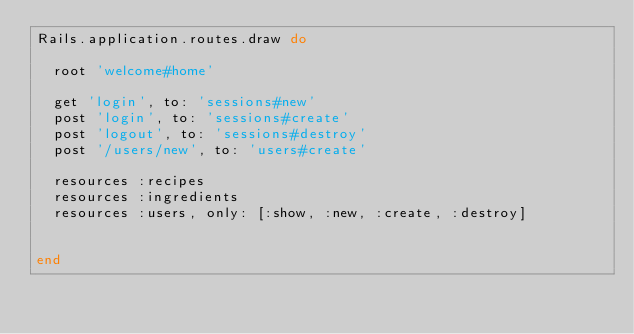<code> <loc_0><loc_0><loc_500><loc_500><_Ruby_>Rails.application.routes.draw do

  root 'welcome#home'

  get 'login', to: 'sessions#new'
  post 'login', to: 'sessions#create'
  post 'logout', to: 'sessions#destroy'
  post '/users/new', to: 'users#create'

  resources :recipes
  resources :ingredients
  resources :users, only: [:show, :new, :create, :destroy]


end
</code> 